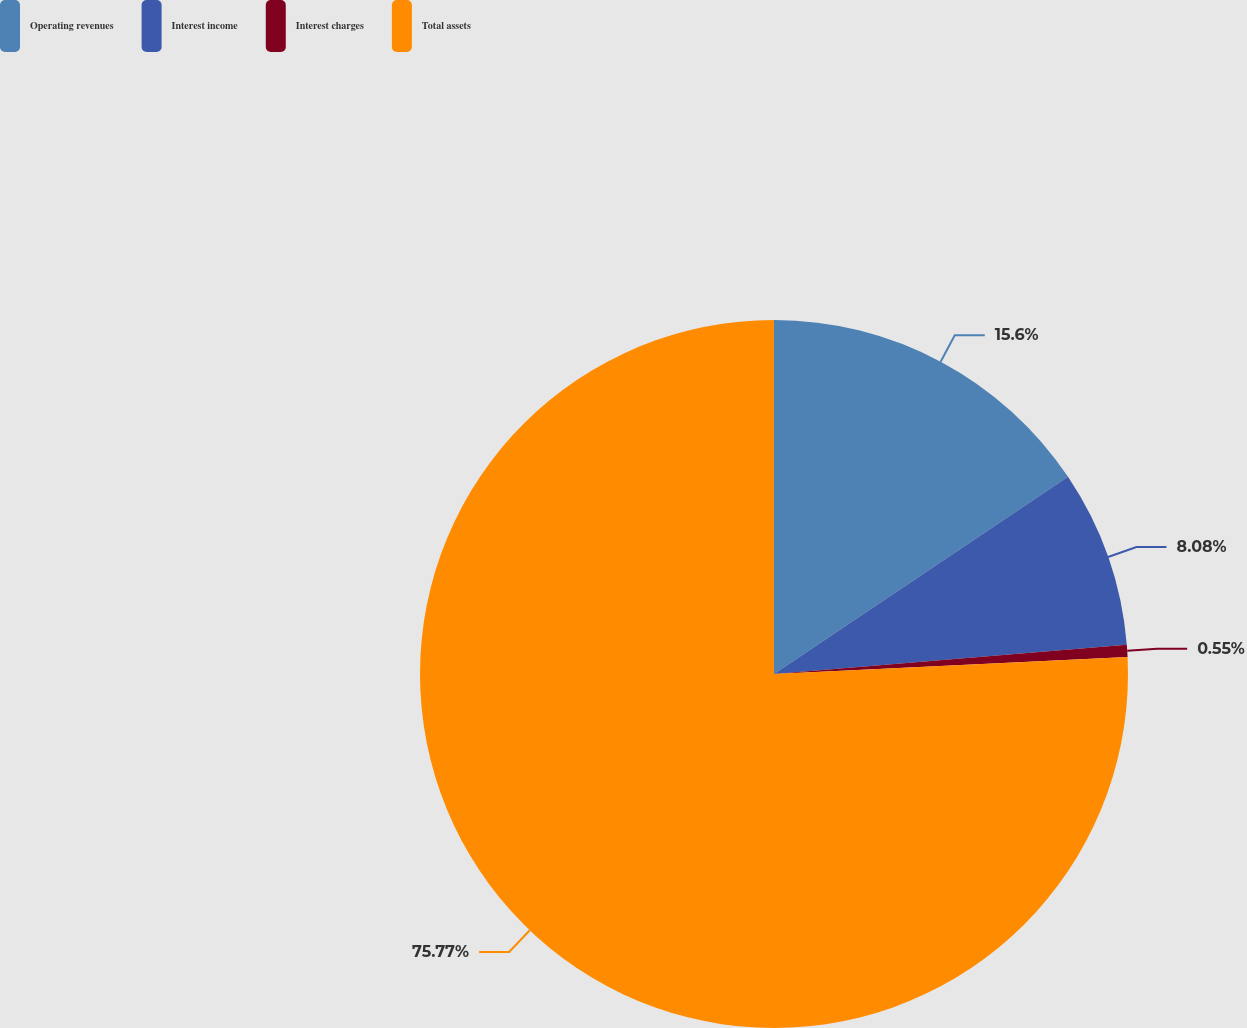Convert chart. <chart><loc_0><loc_0><loc_500><loc_500><pie_chart><fcel>Operating revenues<fcel>Interest income<fcel>Interest charges<fcel>Total assets<nl><fcel>15.6%<fcel>8.08%<fcel>0.55%<fcel>75.77%<nl></chart> 